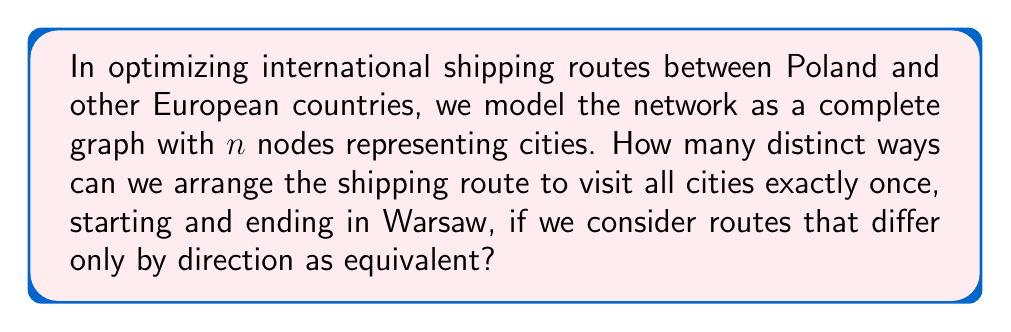Can you answer this question? To solve this problem, we'll use concepts from the representation theory of the symmetric group $S_n$:

1) First, we recognize that this problem is equivalent to counting the number of distinct cycles in $S_n$, where $n$ is the number of cities excluding Warsaw.

2) In the symmetric group $S_n$, the number of $n$-cycles is $(n-1)!$.

3) However, we consider routes that differ only by direction as equivalent. This means we need to divide our count by 2.

4) The formula for the number of distinct routes is thus:

   $$ \text{Number of distinct routes} = \frac{(n-1)!}{2} $$

5) This formula can be derived from the cycle index of $S_n$, which is a key concept in the representation theory of symmetric groups.

6) The cycle index of $S_n$ is given by:

   $$ Z(S_n) = \frac{1}{n!} \sum_{\lambda \vdash n} n_\lambda \prod_{i=1}^n x_i^{a_i} $$

   where $\lambda = (1^{a_1}, 2^{a_2}, ..., n^{a_n})$ is a partition of $n$, and $n_\lambda$ is the number of permutations with cycle type $\lambda$.

7) For our problem, we're interested in the term corresponding to a single $n$-cycle, which has $n_\lambda = (n-1)!$.

8) Dividing by 2 to account for direction equivalence gives us our final formula.
Answer: $\frac{(n-1)!}{2}$ 